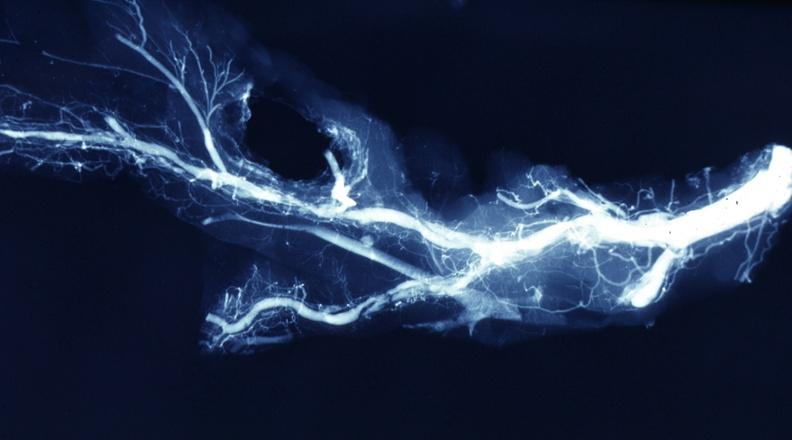s vasculature present?
Answer the question using a single word or phrase. Yes 